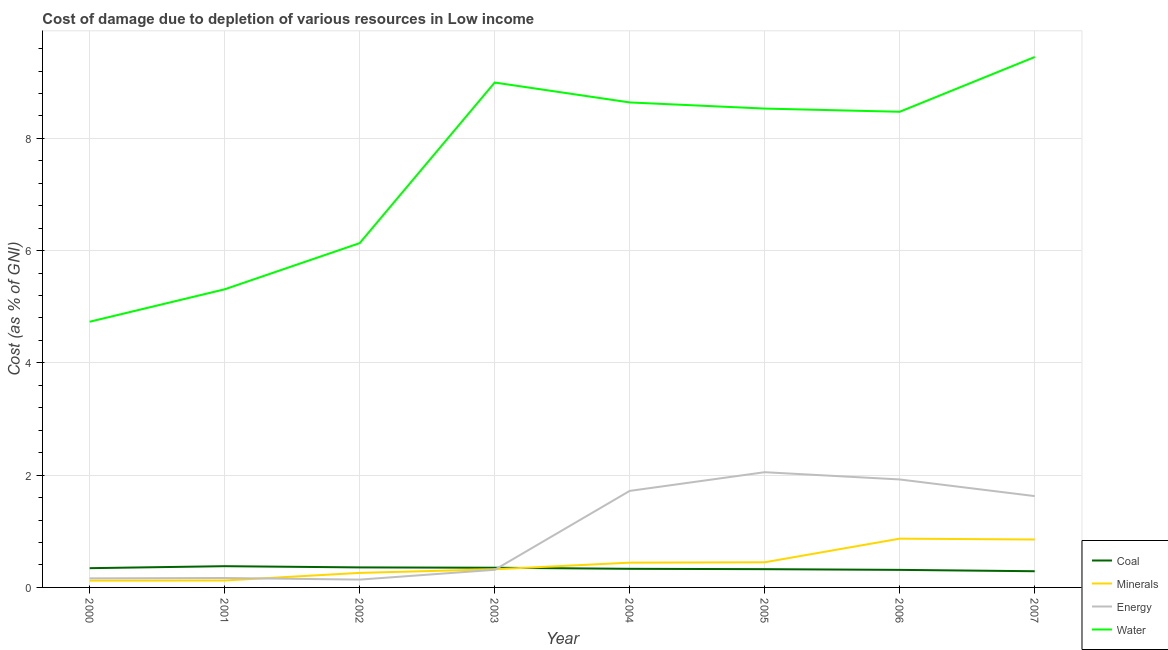Is the number of lines equal to the number of legend labels?
Make the answer very short. Yes. What is the cost of damage due to depletion of water in 2000?
Offer a very short reply. 4.73. Across all years, what is the maximum cost of damage due to depletion of coal?
Provide a succinct answer. 0.38. Across all years, what is the minimum cost of damage due to depletion of coal?
Offer a terse response. 0.29. In which year was the cost of damage due to depletion of energy maximum?
Provide a short and direct response. 2005. What is the total cost of damage due to depletion of water in the graph?
Ensure brevity in your answer.  60.27. What is the difference between the cost of damage due to depletion of minerals in 2005 and that in 2007?
Provide a succinct answer. -0.41. What is the difference between the cost of damage due to depletion of minerals in 2001 and the cost of damage due to depletion of water in 2006?
Your answer should be compact. -8.35. What is the average cost of damage due to depletion of water per year?
Offer a very short reply. 7.53. In the year 2005, what is the difference between the cost of damage due to depletion of minerals and cost of damage due to depletion of coal?
Make the answer very short. 0.12. In how many years, is the cost of damage due to depletion of energy greater than 4.8 %?
Provide a succinct answer. 0. What is the ratio of the cost of damage due to depletion of water in 2004 to that in 2006?
Your answer should be very brief. 1.02. What is the difference between the highest and the second highest cost of damage due to depletion of energy?
Your answer should be very brief. 0.13. What is the difference between the highest and the lowest cost of damage due to depletion of energy?
Ensure brevity in your answer.  1.91. In how many years, is the cost of damage due to depletion of water greater than the average cost of damage due to depletion of water taken over all years?
Ensure brevity in your answer.  5. Is it the case that in every year, the sum of the cost of damage due to depletion of coal and cost of damage due to depletion of energy is greater than the sum of cost of damage due to depletion of minerals and cost of damage due to depletion of water?
Provide a succinct answer. No. Does the cost of damage due to depletion of water monotonically increase over the years?
Offer a very short reply. No. How many years are there in the graph?
Your response must be concise. 8. What is the difference between two consecutive major ticks on the Y-axis?
Your response must be concise. 2. Does the graph contain any zero values?
Your response must be concise. No. Where does the legend appear in the graph?
Provide a short and direct response. Bottom right. How are the legend labels stacked?
Offer a very short reply. Vertical. What is the title of the graph?
Ensure brevity in your answer.  Cost of damage due to depletion of various resources in Low income . Does "Revenue mobilization" appear as one of the legend labels in the graph?
Your response must be concise. No. What is the label or title of the Y-axis?
Provide a succinct answer. Cost (as % of GNI). What is the Cost (as % of GNI) in Coal in 2000?
Offer a very short reply. 0.34. What is the Cost (as % of GNI) of Minerals in 2000?
Your answer should be very brief. 0.12. What is the Cost (as % of GNI) of Energy in 2000?
Your response must be concise. 0.16. What is the Cost (as % of GNI) of Water in 2000?
Ensure brevity in your answer.  4.73. What is the Cost (as % of GNI) in Coal in 2001?
Keep it short and to the point. 0.38. What is the Cost (as % of GNI) in Minerals in 2001?
Provide a succinct answer. 0.12. What is the Cost (as % of GNI) in Energy in 2001?
Keep it short and to the point. 0.17. What is the Cost (as % of GNI) in Water in 2001?
Make the answer very short. 5.31. What is the Cost (as % of GNI) in Coal in 2002?
Offer a very short reply. 0.36. What is the Cost (as % of GNI) in Minerals in 2002?
Provide a succinct answer. 0.26. What is the Cost (as % of GNI) of Energy in 2002?
Your answer should be very brief. 0.14. What is the Cost (as % of GNI) in Water in 2002?
Your answer should be very brief. 6.13. What is the Cost (as % of GNI) of Coal in 2003?
Ensure brevity in your answer.  0.35. What is the Cost (as % of GNI) in Minerals in 2003?
Give a very brief answer. 0.32. What is the Cost (as % of GNI) of Energy in 2003?
Keep it short and to the point. 0.31. What is the Cost (as % of GNI) in Water in 2003?
Keep it short and to the point. 8.99. What is the Cost (as % of GNI) in Coal in 2004?
Make the answer very short. 0.33. What is the Cost (as % of GNI) of Minerals in 2004?
Provide a short and direct response. 0.44. What is the Cost (as % of GNI) of Energy in 2004?
Offer a very short reply. 1.72. What is the Cost (as % of GNI) in Water in 2004?
Offer a terse response. 8.64. What is the Cost (as % of GNI) of Coal in 2005?
Your answer should be compact. 0.33. What is the Cost (as % of GNI) of Minerals in 2005?
Offer a terse response. 0.45. What is the Cost (as % of GNI) in Energy in 2005?
Ensure brevity in your answer.  2.05. What is the Cost (as % of GNI) in Water in 2005?
Make the answer very short. 8.53. What is the Cost (as % of GNI) of Coal in 2006?
Make the answer very short. 0.31. What is the Cost (as % of GNI) of Minerals in 2006?
Your response must be concise. 0.87. What is the Cost (as % of GNI) of Energy in 2006?
Make the answer very short. 1.92. What is the Cost (as % of GNI) in Water in 2006?
Provide a succinct answer. 8.47. What is the Cost (as % of GNI) of Coal in 2007?
Keep it short and to the point. 0.29. What is the Cost (as % of GNI) of Minerals in 2007?
Your response must be concise. 0.85. What is the Cost (as % of GNI) in Energy in 2007?
Make the answer very short. 1.63. What is the Cost (as % of GNI) of Water in 2007?
Keep it short and to the point. 9.45. Across all years, what is the maximum Cost (as % of GNI) of Coal?
Ensure brevity in your answer.  0.38. Across all years, what is the maximum Cost (as % of GNI) of Minerals?
Give a very brief answer. 0.87. Across all years, what is the maximum Cost (as % of GNI) in Energy?
Give a very brief answer. 2.05. Across all years, what is the maximum Cost (as % of GNI) in Water?
Offer a very short reply. 9.45. Across all years, what is the minimum Cost (as % of GNI) in Coal?
Provide a short and direct response. 0.29. Across all years, what is the minimum Cost (as % of GNI) of Minerals?
Give a very brief answer. 0.12. Across all years, what is the minimum Cost (as % of GNI) of Energy?
Provide a short and direct response. 0.14. Across all years, what is the minimum Cost (as % of GNI) in Water?
Offer a very short reply. 4.73. What is the total Cost (as % of GNI) of Coal in the graph?
Keep it short and to the point. 2.69. What is the total Cost (as % of GNI) in Minerals in the graph?
Make the answer very short. 3.44. What is the total Cost (as % of GNI) of Energy in the graph?
Keep it short and to the point. 8.11. What is the total Cost (as % of GNI) of Water in the graph?
Make the answer very short. 60.27. What is the difference between the Cost (as % of GNI) of Coal in 2000 and that in 2001?
Provide a succinct answer. -0.04. What is the difference between the Cost (as % of GNI) in Minerals in 2000 and that in 2001?
Keep it short and to the point. -0. What is the difference between the Cost (as % of GNI) of Energy in 2000 and that in 2001?
Your response must be concise. -0.01. What is the difference between the Cost (as % of GNI) in Water in 2000 and that in 2001?
Your answer should be very brief. -0.58. What is the difference between the Cost (as % of GNI) in Coal in 2000 and that in 2002?
Ensure brevity in your answer.  -0.01. What is the difference between the Cost (as % of GNI) of Minerals in 2000 and that in 2002?
Your answer should be very brief. -0.14. What is the difference between the Cost (as % of GNI) in Energy in 2000 and that in 2002?
Your answer should be compact. 0.02. What is the difference between the Cost (as % of GNI) of Water in 2000 and that in 2002?
Keep it short and to the point. -1.4. What is the difference between the Cost (as % of GNI) of Coal in 2000 and that in 2003?
Your answer should be compact. -0.01. What is the difference between the Cost (as % of GNI) in Minerals in 2000 and that in 2003?
Keep it short and to the point. -0.2. What is the difference between the Cost (as % of GNI) of Energy in 2000 and that in 2003?
Your answer should be compact. -0.15. What is the difference between the Cost (as % of GNI) of Water in 2000 and that in 2003?
Make the answer very short. -4.26. What is the difference between the Cost (as % of GNI) of Coal in 2000 and that in 2004?
Provide a succinct answer. 0.01. What is the difference between the Cost (as % of GNI) of Minerals in 2000 and that in 2004?
Your answer should be very brief. -0.32. What is the difference between the Cost (as % of GNI) of Energy in 2000 and that in 2004?
Your answer should be very brief. -1.56. What is the difference between the Cost (as % of GNI) in Water in 2000 and that in 2004?
Offer a very short reply. -3.91. What is the difference between the Cost (as % of GNI) of Coal in 2000 and that in 2005?
Make the answer very short. 0.02. What is the difference between the Cost (as % of GNI) in Minerals in 2000 and that in 2005?
Your response must be concise. -0.33. What is the difference between the Cost (as % of GNI) in Energy in 2000 and that in 2005?
Provide a succinct answer. -1.89. What is the difference between the Cost (as % of GNI) of Water in 2000 and that in 2005?
Give a very brief answer. -3.8. What is the difference between the Cost (as % of GNI) of Coal in 2000 and that in 2006?
Make the answer very short. 0.03. What is the difference between the Cost (as % of GNI) in Minerals in 2000 and that in 2006?
Ensure brevity in your answer.  -0.75. What is the difference between the Cost (as % of GNI) of Energy in 2000 and that in 2006?
Ensure brevity in your answer.  -1.76. What is the difference between the Cost (as % of GNI) in Water in 2000 and that in 2006?
Provide a succinct answer. -3.74. What is the difference between the Cost (as % of GNI) of Coal in 2000 and that in 2007?
Provide a short and direct response. 0.05. What is the difference between the Cost (as % of GNI) of Minerals in 2000 and that in 2007?
Provide a succinct answer. -0.73. What is the difference between the Cost (as % of GNI) in Energy in 2000 and that in 2007?
Offer a very short reply. -1.47. What is the difference between the Cost (as % of GNI) of Water in 2000 and that in 2007?
Keep it short and to the point. -4.72. What is the difference between the Cost (as % of GNI) in Coal in 2001 and that in 2002?
Keep it short and to the point. 0.02. What is the difference between the Cost (as % of GNI) of Minerals in 2001 and that in 2002?
Give a very brief answer. -0.14. What is the difference between the Cost (as % of GNI) of Energy in 2001 and that in 2002?
Keep it short and to the point. 0.03. What is the difference between the Cost (as % of GNI) in Water in 2001 and that in 2002?
Give a very brief answer. -0.82. What is the difference between the Cost (as % of GNI) of Coal in 2001 and that in 2003?
Your answer should be compact. 0.03. What is the difference between the Cost (as % of GNI) of Minerals in 2001 and that in 2003?
Your answer should be compact. -0.2. What is the difference between the Cost (as % of GNI) of Energy in 2001 and that in 2003?
Your answer should be very brief. -0.15. What is the difference between the Cost (as % of GNI) of Water in 2001 and that in 2003?
Provide a short and direct response. -3.68. What is the difference between the Cost (as % of GNI) of Coal in 2001 and that in 2004?
Your answer should be compact. 0.05. What is the difference between the Cost (as % of GNI) of Minerals in 2001 and that in 2004?
Offer a terse response. -0.32. What is the difference between the Cost (as % of GNI) in Energy in 2001 and that in 2004?
Ensure brevity in your answer.  -1.55. What is the difference between the Cost (as % of GNI) of Water in 2001 and that in 2004?
Your response must be concise. -3.33. What is the difference between the Cost (as % of GNI) in Coal in 2001 and that in 2005?
Offer a very short reply. 0.05. What is the difference between the Cost (as % of GNI) of Minerals in 2001 and that in 2005?
Keep it short and to the point. -0.32. What is the difference between the Cost (as % of GNI) in Energy in 2001 and that in 2005?
Your answer should be compact. -1.89. What is the difference between the Cost (as % of GNI) of Water in 2001 and that in 2005?
Ensure brevity in your answer.  -3.22. What is the difference between the Cost (as % of GNI) in Coal in 2001 and that in 2006?
Offer a very short reply. 0.07. What is the difference between the Cost (as % of GNI) of Minerals in 2001 and that in 2006?
Offer a very short reply. -0.74. What is the difference between the Cost (as % of GNI) of Energy in 2001 and that in 2006?
Your answer should be very brief. -1.76. What is the difference between the Cost (as % of GNI) in Water in 2001 and that in 2006?
Offer a very short reply. -3.16. What is the difference between the Cost (as % of GNI) of Coal in 2001 and that in 2007?
Your answer should be compact. 0.09. What is the difference between the Cost (as % of GNI) in Minerals in 2001 and that in 2007?
Your answer should be very brief. -0.73. What is the difference between the Cost (as % of GNI) in Energy in 2001 and that in 2007?
Keep it short and to the point. -1.46. What is the difference between the Cost (as % of GNI) of Water in 2001 and that in 2007?
Offer a terse response. -4.14. What is the difference between the Cost (as % of GNI) of Coal in 2002 and that in 2003?
Make the answer very short. 0.01. What is the difference between the Cost (as % of GNI) in Minerals in 2002 and that in 2003?
Make the answer very short. -0.06. What is the difference between the Cost (as % of GNI) in Energy in 2002 and that in 2003?
Provide a succinct answer. -0.17. What is the difference between the Cost (as % of GNI) of Water in 2002 and that in 2003?
Provide a short and direct response. -2.86. What is the difference between the Cost (as % of GNI) in Coal in 2002 and that in 2004?
Ensure brevity in your answer.  0.02. What is the difference between the Cost (as % of GNI) of Minerals in 2002 and that in 2004?
Offer a very short reply. -0.18. What is the difference between the Cost (as % of GNI) of Energy in 2002 and that in 2004?
Your answer should be very brief. -1.58. What is the difference between the Cost (as % of GNI) of Water in 2002 and that in 2004?
Offer a very short reply. -2.51. What is the difference between the Cost (as % of GNI) in Coal in 2002 and that in 2005?
Provide a succinct answer. 0.03. What is the difference between the Cost (as % of GNI) of Minerals in 2002 and that in 2005?
Your answer should be very brief. -0.19. What is the difference between the Cost (as % of GNI) in Energy in 2002 and that in 2005?
Keep it short and to the point. -1.91. What is the difference between the Cost (as % of GNI) in Water in 2002 and that in 2005?
Ensure brevity in your answer.  -2.4. What is the difference between the Cost (as % of GNI) in Coal in 2002 and that in 2006?
Provide a short and direct response. 0.04. What is the difference between the Cost (as % of GNI) of Minerals in 2002 and that in 2006?
Your answer should be very brief. -0.61. What is the difference between the Cost (as % of GNI) in Energy in 2002 and that in 2006?
Ensure brevity in your answer.  -1.78. What is the difference between the Cost (as % of GNI) in Water in 2002 and that in 2006?
Make the answer very short. -2.34. What is the difference between the Cost (as % of GNI) in Coal in 2002 and that in 2007?
Keep it short and to the point. 0.07. What is the difference between the Cost (as % of GNI) in Minerals in 2002 and that in 2007?
Offer a very short reply. -0.59. What is the difference between the Cost (as % of GNI) in Energy in 2002 and that in 2007?
Ensure brevity in your answer.  -1.49. What is the difference between the Cost (as % of GNI) in Water in 2002 and that in 2007?
Your answer should be very brief. -3.32. What is the difference between the Cost (as % of GNI) of Coal in 2003 and that in 2004?
Keep it short and to the point. 0.02. What is the difference between the Cost (as % of GNI) of Minerals in 2003 and that in 2004?
Provide a succinct answer. -0.12. What is the difference between the Cost (as % of GNI) in Energy in 2003 and that in 2004?
Offer a terse response. -1.41. What is the difference between the Cost (as % of GNI) in Water in 2003 and that in 2004?
Offer a terse response. 0.35. What is the difference between the Cost (as % of GNI) of Coal in 2003 and that in 2005?
Your answer should be compact. 0.03. What is the difference between the Cost (as % of GNI) in Minerals in 2003 and that in 2005?
Provide a short and direct response. -0.12. What is the difference between the Cost (as % of GNI) of Energy in 2003 and that in 2005?
Offer a terse response. -1.74. What is the difference between the Cost (as % of GNI) of Water in 2003 and that in 2005?
Make the answer very short. 0.46. What is the difference between the Cost (as % of GNI) in Coal in 2003 and that in 2006?
Offer a terse response. 0.04. What is the difference between the Cost (as % of GNI) of Minerals in 2003 and that in 2006?
Make the answer very short. -0.55. What is the difference between the Cost (as % of GNI) of Energy in 2003 and that in 2006?
Ensure brevity in your answer.  -1.61. What is the difference between the Cost (as % of GNI) of Water in 2003 and that in 2006?
Your answer should be very brief. 0.52. What is the difference between the Cost (as % of GNI) of Coal in 2003 and that in 2007?
Provide a short and direct response. 0.06. What is the difference between the Cost (as % of GNI) of Minerals in 2003 and that in 2007?
Make the answer very short. -0.53. What is the difference between the Cost (as % of GNI) of Energy in 2003 and that in 2007?
Provide a short and direct response. -1.31. What is the difference between the Cost (as % of GNI) in Water in 2003 and that in 2007?
Your answer should be very brief. -0.46. What is the difference between the Cost (as % of GNI) in Coal in 2004 and that in 2005?
Ensure brevity in your answer.  0.01. What is the difference between the Cost (as % of GNI) in Minerals in 2004 and that in 2005?
Offer a terse response. -0.01. What is the difference between the Cost (as % of GNI) in Energy in 2004 and that in 2005?
Your answer should be compact. -0.33. What is the difference between the Cost (as % of GNI) in Water in 2004 and that in 2005?
Offer a terse response. 0.11. What is the difference between the Cost (as % of GNI) of Coal in 2004 and that in 2006?
Your answer should be very brief. 0.02. What is the difference between the Cost (as % of GNI) of Minerals in 2004 and that in 2006?
Provide a succinct answer. -0.43. What is the difference between the Cost (as % of GNI) of Energy in 2004 and that in 2006?
Your answer should be compact. -0.2. What is the difference between the Cost (as % of GNI) of Water in 2004 and that in 2006?
Make the answer very short. 0.17. What is the difference between the Cost (as % of GNI) of Coal in 2004 and that in 2007?
Provide a succinct answer. 0.04. What is the difference between the Cost (as % of GNI) of Minerals in 2004 and that in 2007?
Provide a short and direct response. -0.41. What is the difference between the Cost (as % of GNI) of Energy in 2004 and that in 2007?
Make the answer very short. 0.09. What is the difference between the Cost (as % of GNI) in Water in 2004 and that in 2007?
Make the answer very short. -0.81. What is the difference between the Cost (as % of GNI) in Coal in 2005 and that in 2006?
Give a very brief answer. 0.01. What is the difference between the Cost (as % of GNI) of Minerals in 2005 and that in 2006?
Ensure brevity in your answer.  -0.42. What is the difference between the Cost (as % of GNI) in Energy in 2005 and that in 2006?
Offer a terse response. 0.13. What is the difference between the Cost (as % of GNI) in Water in 2005 and that in 2006?
Provide a succinct answer. 0.06. What is the difference between the Cost (as % of GNI) of Coal in 2005 and that in 2007?
Give a very brief answer. 0.04. What is the difference between the Cost (as % of GNI) of Minerals in 2005 and that in 2007?
Make the answer very short. -0.41. What is the difference between the Cost (as % of GNI) of Energy in 2005 and that in 2007?
Provide a short and direct response. 0.43. What is the difference between the Cost (as % of GNI) of Water in 2005 and that in 2007?
Provide a succinct answer. -0.92. What is the difference between the Cost (as % of GNI) of Coal in 2006 and that in 2007?
Offer a terse response. 0.02. What is the difference between the Cost (as % of GNI) in Minerals in 2006 and that in 2007?
Your answer should be very brief. 0.02. What is the difference between the Cost (as % of GNI) of Energy in 2006 and that in 2007?
Ensure brevity in your answer.  0.3. What is the difference between the Cost (as % of GNI) of Water in 2006 and that in 2007?
Provide a succinct answer. -0.98. What is the difference between the Cost (as % of GNI) of Coal in 2000 and the Cost (as % of GNI) of Minerals in 2001?
Provide a short and direct response. 0.22. What is the difference between the Cost (as % of GNI) in Coal in 2000 and the Cost (as % of GNI) in Energy in 2001?
Your answer should be compact. 0.18. What is the difference between the Cost (as % of GNI) of Coal in 2000 and the Cost (as % of GNI) of Water in 2001?
Your answer should be very brief. -4.97. What is the difference between the Cost (as % of GNI) of Minerals in 2000 and the Cost (as % of GNI) of Energy in 2001?
Keep it short and to the point. -0.05. What is the difference between the Cost (as % of GNI) in Minerals in 2000 and the Cost (as % of GNI) in Water in 2001?
Your answer should be very brief. -5.19. What is the difference between the Cost (as % of GNI) of Energy in 2000 and the Cost (as % of GNI) of Water in 2001?
Offer a terse response. -5.15. What is the difference between the Cost (as % of GNI) of Coal in 2000 and the Cost (as % of GNI) of Minerals in 2002?
Offer a very short reply. 0.08. What is the difference between the Cost (as % of GNI) of Coal in 2000 and the Cost (as % of GNI) of Energy in 2002?
Give a very brief answer. 0.2. What is the difference between the Cost (as % of GNI) in Coal in 2000 and the Cost (as % of GNI) in Water in 2002?
Make the answer very short. -5.79. What is the difference between the Cost (as % of GNI) in Minerals in 2000 and the Cost (as % of GNI) in Energy in 2002?
Give a very brief answer. -0.02. What is the difference between the Cost (as % of GNI) of Minerals in 2000 and the Cost (as % of GNI) of Water in 2002?
Provide a succinct answer. -6.01. What is the difference between the Cost (as % of GNI) in Energy in 2000 and the Cost (as % of GNI) in Water in 2002?
Offer a very short reply. -5.97. What is the difference between the Cost (as % of GNI) in Coal in 2000 and the Cost (as % of GNI) in Minerals in 2003?
Offer a terse response. 0.02. What is the difference between the Cost (as % of GNI) in Coal in 2000 and the Cost (as % of GNI) in Energy in 2003?
Keep it short and to the point. 0.03. What is the difference between the Cost (as % of GNI) of Coal in 2000 and the Cost (as % of GNI) of Water in 2003?
Provide a short and direct response. -8.65. What is the difference between the Cost (as % of GNI) of Minerals in 2000 and the Cost (as % of GNI) of Energy in 2003?
Keep it short and to the point. -0.19. What is the difference between the Cost (as % of GNI) in Minerals in 2000 and the Cost (as % of GNI) in Water in 2003?
Ensure brevity in your answer.  -8.87. What is the difference between the Cost (as % of GNI) of Energy in 2000 and the Cost (as % of GNI) of Water in 2003?
Your answer should be very brief. -8.83. What is the difference between the Cost (as % of GNI) in Coal in 2000 and the Cost (as % of GNI) in Minerals in 2004?
Keep it short and to the point. -0.1. What is the difference between the Cost (as % of GNI) in Coal in 2000 and the Cost (as % of GNI) in Energy in 2004?
Provide a short and direct response. -1.38. What is the difference between the Cost (as % of GNI) in Coal in 2000 and the Cost (as % of GNI) in Water in 2004?
Provide a short and direct response. -8.3. What is the difference between the Cost (as % of GNI) in Minerals in 2000 and the Cost (as % of GNI) in Energy in 2004?
Provide a short and direct response. -1.6. What is the difference between the Cost (as % of GNI) of Minerals in 2000 and the Cost (as % of GNI) of Water in 2004?
Ensure brevity in your answer.  -8.52. What is the difference between the Cost (as % of GNI) in Energy in 2000 and the Cost (as % of GNI) in Water in 2004?
Ensure brevity in your answer.  -8.48. What is the difference between the Cost (as % of GNI) in Coal in 2000 and the Cost (as % of GNI) in Minerals in 2005?
Your answer should be compact. -0.1. What is the difference between the Cost (as % of GNI) of Coal in 2000 and the Cost (as % of GNI) of Energy in 2005?
Keep it short and to the point. -1.71. What is the difference between the Cost (as % of GNI) in Coal in 2000 and the Cost (as % of GNI) in Water in 2005?
Provide a short and direct response. -8.19. What is the difference between the Cost (as % of GNI) in Minerals in 2000 and the Cost (as % of GNI) in Energy in 2005?
Provide a succinct answer. -1.93. What is the difference between the Cost (as % of GNI) in Minerals in 2000 and the Cost (as % of GNI) in Water in 2005?
Your response must be concise. -8.41. What is the difference between the Cost (as % of GNI) in Energy in 2000 and the Cost (as % of GNI) in Water in 2005?
Make the answer very short. -8.37. What is the difference between the Cost (as % of GNI) of Coal in 2000 and the Cost (as % of GNI) of Minerals in 2006?
Ensure brevity in your answer.  -0.53. What is the difference between the Cost (as % of GNI) of Coal in 2000 and the Cost (as % of GNI) of Energy in 2006?
Your answer should be very brief. -1.58. What is the difference between the Cost (as % of GNI) of Coal in 2000 and the Cost (as % of GNI) of Water in 2006?
Provide a succinct answer. -8.13. What is the difference between the Cost (as % of GNI) of Minerals in 2000 and the Cost (as % of GNI) of Energy in 2006?
Offer a very short reply. -1.8. What is the difference between the Cost (as % of GNI) in Minerals in 2000 and the Cost (as % of GNI) in Water in 2006?
Make the answer very short. -8.35. What is the difference between the Cost (as % of GNI) of Energy in 2000 and the Cost (as % of GNI) of Water in 2006?
Ensure brevity in your answer.  -8.31. What is the difference between the Cost (as % of GNI) in Coal in 2000 and the Cost (as % of GNI) in Minerals in 2007?
Provide a short and direct response. -0.51. What is the difference between the Cost (as % of GNI) in Coal in 2000 and the Cost (as % of GNI) in Energy in 2007?
Offer a very short reply. -1.28. What is the difference between the Cost (as % of GNI) of Coal in 2000 and the Cost (as % of GNI) of Water in 2007?
Give a very brief answer. -9.11. What is the difference between the Cost (as % of GNI) in Minerals in 2000 and the Cost (as % of GNI) in Energy in 2007?
Give a very brief answer. -1.51. What is the difference between the Cost (as % of GNI) of Minerals in 2000 and the Cost (as % of GNI) of Water in 2007?
Your response must be concise. -9.33. What is the difference between the Cost (as % of GNI) in Energy in 2000 and the Cost (as % of GNI) in Water in 2007?
Your response must be concise. -9.29. What is the difference between the Cost (as % of GNI) of Coal in 2001 and the Cost (as % of GNI) of Minerals in 2002?
Ensure brevity in your answer.  0.12. What is the difference between the Cost (as % of GNI) of Coal in 2001 and the Cost (as % of GNI) of Energy in 2002?
Make the answer very short. 0.24. What is the difference between the Cost (as % of GNI) of Coal in 2001 and the Cost (as % of GNI) of Water in 2002?
Your answer should be compact. -5.76. What is the difference between the Cost (as % of GNI) in Minerals in 2001 and the Cost (as % of GNI) in Energy in 2002?
Give a very brief answer. -0.02. What is the difference between the Cost (as % of GNI) in Minerals in 2001 and the Cost (as % of GNI) in Water in 2002?
Ensure brevity in your answer.  -6.01. What is the difference between the Cost (as % of GNI) of Energy in 2001 and the Cost (as % of GNI) of Water in 2002?
Your answer should be very brief. -5.97. What is the difference between the Cost (as % of GNI) in Coal in 2001 and the Cost (as % of GNI) in Minerals in 2003?
Your response must be concise. 0.06. What is the difference between the Cost (as % of GNI) of Coal in 2001 and the Cost (as % of GNI) of Energy in 2003?
Ensure brevity in your answer.  0.06. What is the difference between the Cost (as % of GNI) in Coal in 2001 and the Cost (as % of GNI) in Water in 2003?
Provide a succinct answer. -8.62. What is the difference between the Cost (as % of GNI) of Minerals in 2001 and the Cost (as % of GNI) of Energy in 2003?
Your answer should be very brief. -0.19. What is the difference between the Cost (as % of GNI) in Minerals in 2001 and the Cost (as % of GNI) in Water in 2003?
Offer a very short reply. -8.87. What is the difference between the Cost (as % of GNI) in Energy in 2001 and the Cost (as % of GNI) in Water in 2003?
Your answer should be very brief. -8.83. What is the difference between the Cost (as % of GNI) in Coal in 2001 and the Cost (as % of GNI) in Minerals in 2004?
Make the answer very short. -0.06. What is the difference between the Cost (as % of GNI) of Coal in 2001 and the Cost (as % of GNI) of Energy in 2004?
Your answer should be very brief. -1.34. What is the difference between the Cost (as % of GNI) in Coal in 2001 and the Cost (as % of GNI) in Water in 2004?
Offer a very short reply. -8.26. What is the difference between the Cost (as % of GNI) of Minerals in 2001 and the Cost (as % of GNI) of Energy in 2004?
Offer a terse response. -1.6. What is the difference between the Cost (as % of GNI) in Minerals in 2001 and the Cost (as % of GNI) in Water in 2004?
Provide a short and direct response. -8.52. What is the difference between the Cost (as % of GNI) in Energy in 2001 and the Cost (as % of GNI) in Water in 2004?
Your response must be concise. -8.47. What is the difference between the Cost (as % of GNI) of Coal in 2001 and the Cost (as % of GNI) of Minerals in 2005?
Provide a succinct answer. -0.07. What is the difference between the Cost (as % of GNI) of Coal in 2001 and the Cost (as % of GNI) of Energy in 2005?
Your answer should be very brief. -1.67. What is the difference between the Cost (as % of GNI) of Coal in 2001 and the Cost (as % of GNI) of Water in 2005?
Your answer should be very brief. -8.15. What is the difference between the Cost (as % of GNI) in Minerals in 2001 and the Cost (as % of GNI) in Energy in 2005?
Your response must be concise. -1.93. What is the difference between the Cost (as % of GNI) in Minerals in 2001 and the Cost (as % of GNI) in Water in 2005?
Your answer should be compact. -8.41. What is the difference between the Cost (as % of GNI) of Energy in 2001 and the Cost (as % of GNI) of Water in 2005?
Offer a very short reply. -8.36. What is the difference between the Cost (as % of GNI) of Coal in 2001 and the Cost (as % of GNI) of Minerals in 2006?
Provide a succinct answer. -0.49. What is the difference between the Cost (as % of GNI) of Coal in 2001 and the Cost (as % of GNI) of Energy in 2006?
Give a very brief answer. -1.55. What is the difference between the Cost (as % of GNI) in Coal in 2001 and the Cost (as % of GNI) in Water in 2006?
Offer a terse response. -8.1. What is the difference between the Cost (as % of GNI) in Minerals in 2001 and the Cost (as % of GNI) in Energy in 2006?
Offer a terse response. -1.8. What is the difference between the Cost (as % of GNI) in Minerals in 2001 and the Cost (as % of GNI) in Water in 2006?
Provide a succinct answer. -8.35. What is the difference between the Cost (as % of GNI) in Energy in 2001 and the Cost (as % of GNI) in Water in 2006?
Your answer should be very brief. -8.31. What is the difference between the Cost (as % of GNI) of Coal in 2001 and the Cost (as % of GNI) of Minerals in 2007?
Your answer should be compact. -0.48. What is the difference between the Cost (as % of GNI) of Coal in 2001 and the Cost (as % of GNI) of Energy in 2007?
Your answer should be very brief. -1.25. What is the difference between the Cost (as % of GNI) of Coal in 2001 and the Cost (as % of GNI) of Water in 2007?
Provide a short and direct response. -9.07. What is the difference between the Cost (as % of GNI) of Minerals in 2001 and the Cost (as % of GNI) of Energy in 2007?
Offer a terse response. -1.5. What is the difference between the Cost (as % of GNI) of Minerals in 2001 and the Cost (as % of GNI) of Water in 2007?
Offer a very short reply. -9.33. What is the difference between the Cost (as % of GNI) of Energy in 2001 and the Cost (as % of GNI) of Water in 2007?
Offer a very short reply. -9.28. What is the difference between the Cost (as % of GNI) of Coal in 2002 and the Cost (as % of GNI) of Minerals in 2003?
Ensure brevity in your answer.  0.03. What is the difference between the Cost (as % of GNI) of Coal in 2002 and the Cost (as % of GNI) of Energy in 2003?
Your answer should be very brief. 0.04. What is the difference between the Cost (as % of GNI) in Coal in 2002 and the Cost (as % of GNI) in Water in 2003?
Give a very brief answer. -8.64. What is the difference between the Cost (as % of GNI) in Minerals in 2002 and the Cost (as % of GNI) in Energy in 2003?
Give a very brief answer. -0.05. What is the difference between the Cost (as % of GNI) in Minerals in 2002 and the Cost (as % of GNI) in Water in 2003?
Provide a short and direct response. -8.74. What is the difference between the Cost (as % of GNI) of Energy in 2002 and the Cost (as % of GNI) of Water in 2003?
Offer a terse response. -8.86. What is the difference between the Cost (as % of GNI) in Coal in 2002 and the Cost (as % of GNI) in Minerals in 2004?
Give a very brief answer. -0.08. What is the difference between the Cost (as % of GNI) of Coal in 2002 and the Cost (as % of GNI) of Energy in 2004?
Your answer should be compact. -1.36. What is the difference between the Cost (as % of GNI) of Coal in 2002 and the Cost (as % of GNI) of Water in 2004?
Ensure brevity in your answer.  -8.28. What is the difference between the Cost (as % of GNI) in Minerals in 2002 and the Cost (as % of GNI) in Energy in 2004?
Your response must be concise. -1.46. What is the difference between the Cost (as % of GNI) of Minerals in 2002 and the Cost (as % of GNI) of Water in 2004?
Make the answer very short. -8.38. What is the difference between the Cost (as % of GNI) of Energy in 2002 and the Cost (as % of GNI) of Water in 2004?
Offer a very short reply. -8.5. What is the difference between the Cost (as % of GNI) in Coal in 2002 and the Cost (as % of GNI) in Minerals in 2005?
Make the answer very short. -0.09. What is the difference between the Cost (as % of GNI) in Coal in 2002 and the Cost (as % of GNI) in Energy in 2005?
Provide a succinct answer. -1.7. What is the difference between the Cost (as % of GNI) in Coal in 2002 and the Cost (as % of GNI) in Water in 2005?
Your response must be concise. -8.17. What is the difference between the Cost (as % of GNI) of Minerals in 2002 and the Cost (as % of GNI) of Energy in 2005?
Keep it short and to the point. -1.79. What is the difference between the Cost (as % of GNI) in Minerals in 2002 and the Cost (as % of GNI) in Water in 2005?
Your answer should be very brief. -8.27. What is the difference between the Cost (as % of GNI) in Energy in 2002 and the Cost (as % of GNI) in Water in 2005?
Offer a terse response. -8.39. What is the difference between the Cost (as % of GNI) of Coal in 2002 and the Cost (as % of GNI) of Minerals in 2006?
Your response must be concise. -0.51. What is the difference between the Cost (as % of GNI) of Coal in 2002 and the Cost (as % of GNI) of Energy in 2006?
Ensure brevity in your answer.  -1.57. What is the difference between the Cost (as % of GNI) in Coal in 2002 and the Cost (as % of GNI) in Water in 2006?
Give a very brief answer. -8.12. What is the difference between the Cost (as % of GNI) of Minerals in 2002 and the Cost (as % of GNI) of Energy in 2006?
Ensure brevity in your answer.  -1.66. What is the difference between the Cost (as % of GNI) in Minerals in 2002 and the Cost (as % of GNI) in Water in 2006?
Give a very brief answer. -8.22. What is the difference between the Cost (as % of GNI) of Energy in 2002 and the Cost (as % of GNI) of Water in 2006?
Your answer should be very brief. -8.33. What is the difference between the Cost (as % of GNI) of Coal in 2002 and the Cost (as % of GNI) of Minerals in 2007?
Keep it short and to the point. -0.5. What is the difference between the Cost (as % of GNI) in Coal in 2002 and the Cost (as % of GNI) in Energy in 2007?
Provide a succinct answer. -1.27. What is the difference between the Cost (as % of GNI) of Coal in 2002 and the Cost (as % of GNI) of Water in 2007?
Offer a very short reply. -9.09. What is the difference between the Cost (as % of GNI) in Minerals in 2002 and the Cost (as % of GNI) in Energy in 2007?
Your response must be concise. -1.37. What is the difference between the Cost (as % of GNI) of Minerals in 2002 and the Cost (as % of GNI) of Water in 2007?
Your answer should be very brief. -9.19. What is the difference between the Cost (as % of GNI) in Energy in 2002 and the Cost (as % of GNI) in Water in 2007?
Provide a succinct answer. -9.31. What is the difference between the Cost (as % of GNI) in Coal in 2003 and the Cost (as % of GNI) in Minerals in 2004?
Your response must be concise. -0.09. What is the difference between the Cost (as % of GNI) of Coal in 2003 and the Cost (as % of GNI) of Energy in 2004?
Ensure brevity in your answer.  -1.37. What is the difference between the Cost (as % of GNI) in Coal in 2003 and the Cost (as % of GNI) in Water in 2004?
Offer a very short reply. -8.29. What is the difference between the Cost (as % of GNI) of Minerals in 2003 and the Cost (as % of GNI) of Energy in 2004?
Give a very brief answer. -1.4. What is the difference between the Cost (as % of GNI) in Minerals in 2003 and the Cost (as % of GNI) in Water in 2004?
Keep it short and to the point. -8.32. What is the difference between the Cost (as % of GNI) of Energy in 2003 and the Cost (as % of GNI) of Water in 2004?
Your answer should be very brief. -8.33. What is the difference between the Cost (as % of GNI) in Coal in 2003 and the Cost (as % of GNI) in Minerals in 2005?
Make the answer very short. -0.1. What is the difference between the Cost (as % of GNI) of Coal in 2003 and the Cost (as % of GNI) of Energy in 2005?
Offer a terse response. -1.7. What is the difference between the Cost (as % of GNI) of Coal in 2003 and the Cost (as % of GNI) of Water in 2005?
Keep it short and to the point. -8.18. What is the difference between the Cost (as % of GNI) in Minerals in 2003 and the Cost (as % of GNI) in Energy in 2005?
Offer a very short reply. -1.73. What is the difference between the Cost (as % of GNI) in Minerals in 2003 and the Cost (as % of GNI) in Water in 2005?
Offer a terse response. -8.21. What is the difference between the Cost (as % of GNI) of Energy in 2003 and the Cost (as % of GNI) of Water in 2005?
Make the answer very short. -8.22. What is the difference between the Cost (as % of GNI) in Coal in 2003 and the Cost (as % of GNI) in Minerals in 2006?
Provide a succinct answer. -0.52. What is the difference between the Cost (as % of GNI) in Coal in 2003 and the Cost (as % of GNI) in Energy in 2006?
Make the answer very short. -1.57. What is the difference between the Cost (as % of GNI) of Coal in 2003 and the Cost (as % of GNI) of Water in 2006?
Your answer should be very brief. -8.12. What is the difference between the Cost (as % of GNI) in Minerals in 2003 and the Cost (as % of GNI) in Energy in 2006?
Your answer should be very brief. -1.6. What is the difference between the Cost (as % of GNI) of Minerals in 2003 and the Cost (as % of GNI) of Water in 2006?
Your answer should be very brief. -8.15. What is the difference between the Cost (as % of GNI) in Energy in 2003 and the Cost (as % of GNI) in Water in 2006?
Provide a succinct answer. -8.16. What is the difference between the Cost (as % of GNI) in Coal in 2003 and the Cost (as % of GNI) in Minerals in 2007?
Keep it short and to the point. -0.5. What is the difference between the Cost (as % of GNI) in Coal in 2003 and the Cost (as % of GNI) in Energy in 2007?
Provide a short and direct response. -1.28. What is the difference between the Cost (as % of GNI) of Coal in 2003 and the Cost (as % of GNI) of Water in 2007?
Give a very brief answer. -9.1. What is the difference between the Cost (as % of GNI) of Minerals in 2003 and the Cost (as % of GNI) of Energy in 2007?
Your answer should be compact. -1.3. What is the difference between the Cost (as % of GNI) of Minerals in 2003 and the Cost (as % of GNI) of Water in 2007?
Your answer should be compact. -9.13. What is the difference between the Cost (as % of GNI) of Energy in 2003 and the Cost (as % of GNI) of Water in 2007?
Provide a short and direct response. -9.14. What is the difference between the Cost (as % of GNI) in Coal in 2004 and the Cost (as % of GNI) in Minerals in 2005?
Keep it short and to the point. -0.12. What is the difference between the Cost (as % of GNI) of Coal in 2004 and the Cost (as % of GNI) of Energy in 2005?
Your answer should be compact. -1.72. What is the difference between the Cost (as % of GNI) in Coal in 2004 and the Cost (as % of GNI) in Water in 2005?
Offer a terse response. -8.2. What is the difference between the Cost (as % of GNI) of Minerals in 2004 and the Cost (as % of GNI) of Energy in 2005?
Offer a terse response. -1.61. What is the difference between the Cost (as % of GNI) in Minerals in 2004 and the Cost (as % of GNI) in Water in 2005?
Your response must be concise. -8.09. What is the difference between the Cost (as % of GNI) of Energy in 2004 and the Cost (as % of GNI) of Water in 2005?
Provide a succinct answer. -6.81. What is the difference between the Cost (as % of GNI) in Coal in 2004 and the Cost (as % of GNI) in Minerals in 2006?
Offer a terse response. -0.54. What is the difference between the Cost (as % of GNI) in Coal in 2004 and the Cost (as % of GNI) in Energy in 2006?
Provide a succinct answer. -1.59. What is the difference between the Cost (as % of GNI) of Coal in 2004 and the Cost (as % of GNI) of Water in 2006?
Make the answer very short. -8.14. What is the difference between the Cost (as % of GNI) in Minerals in 2004 and the Cost (as % of GNI) in Energy in 2006?
Keep it short and to the point. -1.48. What is the difference between the Cost (as % of GNI) of Minerals in 2004 and the Cost (as % of GNI) of Water in 2006?
Your answer should be compact. -8.03. What is the difference between the Cost (as % of GNI) in Energy in 2004 and the Cost (as % of GNI) in Water in 2006?
Ensure brevity in your answer.  -6.75. What is the difference between the Cost (as % of GNI) of Coal in 2004 and the Cost (as % of GNI) of Minerals in 2007?
Offer a terse response. -0.52. What is the difference between the Cost (as % of GNI) of Coal in 2004 and the Cost (as % of GNI) of Energy in 2007?
Provide a succinct answer. -1.3. What is the difference between the Cost (as % of GNI) of Coal in 2004 and the Cost (as % of GNI) of Water in 2007?
Give a very brief answer. -9.12. What is the difference between the Cost (as % of GNI) of Minerals in 2004 and the Cost (as % of GNI) of Energy in 2007?
Keep it short and to the point. -1.19. What is the difference between the Cost (as % of GNI) in Minerals in 2004 and the Cost (as % of GNI) in Water in 2007?
Give a very brief answer. -9.01. What is the difference between the Cost (as % of GNI) of Energy in 2004 and the Cost (as % of GNI) of Water in 2007?
Offer a terse response. -7.73. What is the difference between the Cost (as % of GNI) of Coal in 2005 and the Cost (as % of GNI) of Minerals in 2006?
Your answer should be compact. -0.54. What is the difference between the Cost (as % of GNI) of Coal in 2005 and the Cost (as % of GNI) of Energy in 2006?
Offer a very short reply. -1.6. What is the difference between the Cost (as % of GNI) in Coal in 2005 and the Cost (as % of GNI) in Water in 2006?
Your answer should be compact. -8.15. What is the difference between the Cost (as % of GNI) in Minerals in 2005 and the Cost (as % of GNI) in Energy in 2006?
Keep it short and to the point. -1.48. What is the difference between the Cost (as % of GNI) in Minerals in 2005 and the Cost (as % of GNI) in Water in 2006?
Keep it short and to the point. -8.03. What is the difference between the Cost (as % of GNI) in Energy in 2005 and the Cost (as % of GNI) in Water in 2006?
Ensure brevity in your answer.  -6.42. What is the difference between the Cost (as % of GNI) of Coal in 2005 and the Cost (as % of GNI) of Minerals in 2007?
Offer a terse response. -0.53. What is the difference between the Cost (as % of GNI) of Coal in 2005 and the Cost (as % of GNI) of Energy in 2007?
Your answer should be very brief. -1.3. What is the difference between the Cost (as % of GNI) in Coal in 2005 and the Cost (as % of GNI) in Water in 2007?
Your answer should be very brief. -9.12. What is the difference between the Cost (as % of GNI) of Minerals in 2005 and the Cost (as % of GNI) of Energy in 2007?
Provide a succinct answer. -1.18. What is the difference between the Cost (as % of GNI) in Minerals in 2005 and the Cost (as % of GNI) in Water in 2007?
Ensure brevity in your answer.  -9. What is the difference between the Cost (as % of GNI) in Energy in 2005 and the Cost (as % of GNI) in Water in 2007?
Keep it short and to the point. -7.4. What is the difference between the Cost (as % of GNI) of Coal in 2006 and the Cost (as % of GNI) of Minerals in 2007?
Ensure brevity in your answer.  -0.54. What is the difference between the Cost (as % of GNI) of Coal in 2006 and the Cost (as % of GNI) of Energy in 2007?
Your answer should be very brief. -1.31. What is the difference between the Cost (as % of GNI) of Coal in 2006 and the Cost (as % of GNI) of Water in 2007?
Offer a terse response. -9.14. What is the difference between the Cost (as % of GNI) in Minerals in 2006 and the Cost (as % of GNI) in Energy in 2007?
Provide a succinct answer. -0.76. What is the difference between the Cost (as % of GNI) of Minerals in 2006 and the Cost (as % of GNI) of Water in 2007?
Offer a terse response. -8.58. What is the difference between the Cost (as % of GNI) of Energy in 2006 and the Cost (as % of GNI) of Water in 2007?
Provide a short and direct response. -7.53. What is the average Cost (as % of GNI) of Coal per year?
Give a very brief answer. 0.34. What is the average Cost (as % of GNI) of Minerals per year?
Ensure brevity in your answer.  0.43. What is the average Cost (as % of GNI) in Energy per year?
Provide a succinct answer. 1.01. What is the average Cost (as % of GNI) of Water per year?
Your response must be concise. 7.53. In the year 2000, what is the difference between the Cost (as % of GNI) of Coal and Cost (as % of GNI) of Minerals?
Your answer should be very brief. 0.22. In the year 2000, what is the difference between the Cost (as % of GNI) in Coal and Cost (as % of GNI) in Energy?
Provide a succinct answer. 0.18. In the year 2000, what is the difference between the Cost (as % of GNI) in Coal and Cost (as % of GNI) in Water?
Provide a succinct answer. -4.39. In the year 2000, what is the difference between the Cost (as % of GNI) in Minerals and Cost (as % of GNI) in Energy?
Your answer should be compact. -0.04. In the year 2000, what is the difference between the Cost (as % of GNI) in Minerals and Cost (as % of GNI) in Water?
Offer a very short reply. -4.61. In the year 2000, what is the difference between the Cost (as % of GNI) of Energy and Cost (as % of GNI) of Water?
Ensure brevity in your answer.  -4.57. In the year 2001, what is the difference between the Cost (as % of GNI) in Coal and Cost (as % of GNI) in Minerals?
Give a very brief answer. 0.25. In the year 2001, what is the difference between the Cost (as % of GNI) in Coal and Cost (as % of GNI) in Energy?
Your response must be concise. 0.21. In the year 2001, what is the difference between the Cost (as % of GNI) of Coal and Cost (as % of GNI) of Water?
Provide a succinct answer. -4.93. In the year 2001, what is the difference between the Cost (as % of GNI) of Minerals and Cost (as % of GNI) of Energy?
Keep it short and to the point. -0.04. In the year 2001, what is the difference between the Cost (as % of GNI) in Minerals and Cost (as % of GNI) in Water?
Give a very brief answer. -5.19. In the year 2001, what is the difference between the Cost (as % of GNI) in Energy and Cost (as % of GNI) in Water?
Offer a terse response. -5.14. In the year 2002, what is the difference between the Cost (as % of GNI) of Coal and Cost (as % of GNI) of Minerals?
Your answer should be compact. 0.1. In the year 2002, what is the difference between the Cost (as % of GNI) in Coal and Cost (as % of GNI) in Energy?
Give a very brief answer. 0.22. In the year 2002, what is the difference between the Cost (as % of GNI) of Coal and Cost (as % of GNI) of Water?
Make the answer very short. -5.78. In the year 2002, what is the difference between the Cost (as % of GNI) of Minerals and Cost (as % of GNI) of Energy?
Give a very brief answer. 0.12. In the year 2002, what is the difference between the Cost (as % of GNI) in Minerals and Cost (as % of GNI) in Water?
Provide a succinct answer. -5.87. In the year 2002, what is the difference between the Cost (as % of GNI) of Energy and Cost (as % of GNI) of Water?
Ensure brevity in your answer.  -5.99. In the year 2003, what is the difference between the Cost (as % of GNI) of Coal and Cost (as % of GNI) of Minerals?
Your answer should be very brief. 0.03. In the year 2003, what is the difference between the Cost (as % of GNI) of Coal and Cost (as % of GNI) of Energy?
Your answer should be very brief. 0.04. In the year 2003, what is the difference between the Cost (as % of GNI) in Coal and Cost (as % of GNI) in Water?
Your answer should be compact. -8.64. In the year 2003, what is the difference between the Cost (as % of GNI) in Minerals and Cost (as % of GNI) in Energy?
Your response must be concise. 0.01. In the year 2003, what is the difference between the Cost (as % of GNI) in Minerals and Cost (as % of GNI) in Water?
Keep it short and to the point. -8.67. In the year 2003, what is the difference between the Cost (as % of GNI) of Energy and Cost (as % of GNI) of Water?
Offer a very short reply. -8.68. In the year 2004, what is the difference between the Cost (as % of GNI) of Coal and Cost (as % of GNI) of Minerals?
Make the answer very short. -0.11. In the year 2004, what is the difference between the Cost (as % of GNI) in Coal and Cost (as % of GNI) in Energy?
Your answer should be compact. -1.39. In the year 2004, what is the difference between the Cost (as % of GNI) in Coal and Cost (as % of GNI) in Water?
Ensure brevity in your answer.  -8.31. In the year 2004, what is the difference between the Cost (as % of GNI) of Minerals and Cost (as % of GNI) of Energy?
Your response must be concise. -1.28. In the year 2004, what is the difference between the Cost (as % of GNI) of Minerals and Cost (as % of GNI) of Water?
Ensure brevity in your answer.  -8.2. In the year 2004, what is the difference between the Cost (as % of GNI) of Energy and Cost (as % of GNI) of Water?
Provide a succinct answer. -6.92. In the year 2005, what is the difference between the Cost (as % of GNI) of Coal and Cost (as % of GNI) of Minerals?
Your answer should be very brief. -0.12. In the year 2005, what is the difference between the Cost (as % of GNI) of Coal and Cost (as % of GNI) of Energy?
Offer a terse response. -1.73. In the year 2005, what is the difference between the Cost (as % of GNI) of Coal and Cost (as % of GNI) of Water?
Your answer should be very brief. -8.21. In the year 2005, what is the difference between the Cost (as % of GNI) in Minerals and Cost (as % of GNI) in Energy?
Make the answer very short. -1.6. In the year 2005, what is the difference between the Cost (as % of GNI) in Minerals and Cost (as % of GNI) in Water?
Offer a terse response. -8.08. In the year 2005, what is the difference between the Cost (as % of GNI) of Energy and Cost (as % of GNI) of Water?
Offer a terse response. -6.48. In the year 2006, what is the difference between the Cost (as % of GNI) of Coal and Cost (as % of GNI) of Minerals?
Your answer should be very brief. -0.56. In the year 2006, what is the difference between the Cost (as % of GNI) in Coal and Cost (as % of GNI) in Energy?
Provide a succinct answer. -1.61. In the year 2006, what is the difference between the Cost (as % of GNI) of Coal and Cost (as % of GNI) of Water?
Offer a terse response. -8.16. In the year 2006, what is the difference between the Cost (as % of GNI) of Minerals and Cost (as % of GNI) of Energy?
Ensure brevity in your answer.  -1.05. In the year 2006, what is the difference between the Cost (as % of GNI) in Minerals and Cost (as % of GNI) in Water?
Your answer should be very brief. -7.61. In the year 2006, what is the difference between the Cost (as % of GNI) in Energy and Cost (as % of GNI) in Water?
Offer a very short reply. -6.55. In the year 2007, what is the difference between the Cost (as % of GNI) in Coal and Cost (as % of GNI) in Minerals?
Your response must be concise. -0.57. In the year 2007, what is the difference between the Cost (as % of GNI) of Coal and Cost (as % of GNI) of Energy?
Provide a succinct answer. -1.34. In the year 2007, what is the difference between the Cost (as % of GNI) of Coal and Cost (as % of GNI) of Water?
Your answer should be compact. -9.16. In the year 2007, what is the difference between the Cost (as % of GNI) in Minerals and Cost (as % of GNI) in Energy?
Offer a terse response. -0.77. In the year 2007, what is the difference between the Cost (as % of GNI) of Minerals and Cost (as % of GNI) of Water?
Offer a terse response. -8.6. In the year 2007, what is the difference between the Cost (as % of GNI) in Energy and Cost (as % of GNI) in Water?
Your answer should be very brief. -7.82. What is the ratio of the Cost (as % of GNI) in Coal in 2000 to that in 2001?
Offer a terse response. 0.91. What is the ratio of the Cost (as % of GNI) in Minerals in 2000 to that in 2001?
Keep it short and to the point. 0.98. What is the ratio of the Cost (as % of GNI) in Energy in 2000 to that in 2001?
Offer a terse response. 0.96. What is the ratio of the Cost (as % of GNI) in Water in 2000 to that in 2001?
Offer a terse response. 0.89. What is the ratio of the Cost (as % of GNI) of Coal in 2000 to that in 2002?
Provide a succinct answer. 0.96. What is the ratio of the Cost (as % of GNI) of Minerals in 2000 to that in 2002?
Provide a short and direct response. 0.47. What is the ratio of the Cost (as % of GNI) in Energy in 2000 to that in 2002?
Your answer should be very brief. 1.16. What is the ratio of the Cost (as % of GNI) of Water in 2000 to that in 2002?
Provide a short and direct response. 0.77. What is the ratio of the Cost (as % of GNI) of Coal in 2000 to that in 2003?
Offer a very short reply. 0.98. What is the ratio of the Cost (as % of GNI) of Minerals in 2000 to that in 2003?
Your answer should be very brief. 0.38. What is the ratio of the Cost (as % of GNI) in Energy in 2000 to that in 2003?
Make the answer very short. 0.51. What is the ratio of the Cost (as % of GNI) in Water in 2000 to that in 2003?
Provide a succinct answer. 0.53. What is the ratio of the Cost (as % of GNI) in Coal in 2000 to that in 2004?
Provide a succinct answer. 1.03. What is the ratio of the Cost (as % of GNI) in Minerals in 2000 to that in 2004?
Give a very brief answer. 0.28. What is the ratio of the Cost (as % of GNI) in Energy in 2000 to that in 2004?
Provide a short and direct response. 0.09. What is the ratio of the Cost (as % of GNI) of Water in 2000 to that in 2004?
Your answer should be compact. 0.55. What is the ratio of the Cost (as % of GNI) of Coal in 2000 to that in 2005?
Your response must be concise. 1.05. What is the ratio of the Cost (as % of GNI) in Minerals in 2000 to that in 2005?
Your answer should be compact. 0.27. What is the ratio of the Cost (as % of GNI) of Energy in 2000 to that in 2005?
Make the answer very short. 0.08. What is the ratio of the Cost (as % of GNI) of Water in 2000 to that in 2005?
Your answer should be very brief. 0.55. What is the ratio of the Cost (as % of GNI) in Coal in 2000 to that in 2006?
Keep it short and to the point. 1.1. What is the ratio of the Cost (as % of GNI) in Minerals in 2000 to that in 2006?
Make the answer very short. 0.14. What is the ratio of the Cost (as % of GNI) in Energy in 2000 to that in 2006?
Ensure brevity in your answer.  0.08. What is the ratio of the Cost (as % of GNI) of Water in 2000 to that in 2006?
Your answer should be compact. 0.56. What is the ratio of the Cost (as % of GNI) of Coal in 2000 to that in 2007?
Give a very brief answer. 1.19. What is the ratio of the Cost (as % of GNI) of Minerals in 2000 to that in 2007?
Keep it short and to the point. 0.14. What is the ratio of the Cost (as % of GNI) of Energy in 2000 to that in 2007?
Your response must be concise. 0.1. What is the ratio of the Cost (as % of GNI) in Water in 2000 to that in 2007?
Keep it short and to the point. 0.5. What is the ratio of the Cost (as % of GNI) in Coal in 2001 to that in 2002?
Ensure brevity in your answer.  1.06. What is the ratio of the Cost (as % of GNI) in Minerals in 2001 to that in 2002?
Your answer should be very brief. 0.48. What is the ratio of the Cost (as % of GNI) in Energy in 2001 to that in 2002?
Make the answer very short. 1.21. What is the ratio of the Cost (as % of GNI) in Water in 2001 to that in 2002?
Provide a succinct answer. 0.87. What is the ratio of the Cost (as % of GNI) of Coal in 2001 to that in 2003?
Offer a terse response. 1.08. What is the ratio of the Cost (as % of GNI) of Minerals in 2001 to that in 2003?
Offer a very short reply. 0.38. What is the ratio of the Cost (as % of GNI) in Energy in 2001 to that in 2003?
Your answer should be very brief. 0.54. What is the ratio of the Cost (as % of GNI) in Water in 2001 to that in 2003?
Give a very brief answer. 0.59. What is the ratio of the Cost (as % of GNI) of Coal in 2001 to that in 2004?
Ensure brevity in your answer.  1.14. What is the ratio of the Cost (as % of GNI) of Minerals in 2001 to that in 2004?
Offer a very short reply. 0.28. What is the ratio of the Cost (as % of GNI) in Energy in 2001 to that in 2004?
Give a very brief answer. 0.1. What is the ratio of the Cost (as % of GNI) of Water in 2001 to that in 2004?
Your answer should be compact. 0.61. What is the ratio of the Cost (as % of GNI) of Coal in 2001 to that in 2005?
Your response must be concise. 1.16. What is the ratio of the Cost (as % of GNI) of Minerals in 2001 to that in 2005?
Provide a short and direct response. 0.28. What is the ratio of the Cost (as % of GNI) in Energy in 2001 to that in 2005?
Give a very brief answer. 0.08. What is the ratio of the Cost (as % of GNI) of Water in 2001 to that in 2005?
Keep it short and to the point. 0.62. What is the ratio of the Cost (as % of GNI) in Coal in 2001 to that in 2006?
Provide a succinct answer. 1.21. What is the ratio of the Cost (as % of GNI) of Minerals in 2001 to that in 2006?
Your answer should be compact. 0.14. What is the ratio of the Cost (as % of GNI) of Energy in 2001 to that in 2006?
Ensure brevity in your answer.  0.09. What is the ratio of the Cost (as % of GNI) in Water in 2001 to that in 2006?
Keep it short and to the point. 0.63. What is the ratio of the Cost (as % of GNI) in Coal in 2001 to that in 2007?
Provide a short and direct response. 1.31. What is the ratio of the Cost (as % of GNI) in Minerals in 2001 to that in 2007?
Make the answer very short. 0.14. What is the ratio of the Cost (as % of GNI) in Energy in 2001 to that in 2007?
Offer a terse response. 0.1. What is the ratio of the Cost (as % of GNI) in Water in 2001 to that in 2007?
Ensure brevity in your answer.  0.56. What is the ratio of the Cost (as % of GNI) of Coal in 2002 to that in 2003?
Provide a short and direct response. 1.02. What is the ratio of the Cost (as % of GNI) in Minerals in 2002 to that in 2003?
Ensure brevity in your answer.  0.8. What is the ratio of the Cost (as % of GNI) in Energy in 2002 to that in 2003?
Give a very brief answer. 0.44. What is the ratio of the Cost (as % of GNI) in Water in 2002 to that in 2003?
Your response must be concise. 0.68. What is the ratio of the Cost (as % of GNI) of Coal in 2002 to that in 2004?
Offer a very short reply. 1.07. What is the ratio of the Cost (as % of GNI) in Minerals in 2002 to that in 2004?
Keep it short and to the point. 0.59. What is the ratio of the Cost (as % of GNI) of Energy in 2002 to that in 2004?
Give a very brief answer. 0.08. What is the ratio of the Cost (as % of GNI) of Water in 2002 to that in 2004?
Keep it short and to the point. 0.71. What is the ratio of the Cost (as % of GNI) of Coal in 2002 to that in 2005?
Your response must be concise. 1.1. What is the ratio of the Cost (as % of GNI) of Minerals in 2002 to that in 2005?
Give a very brief answer. 0.58. What is the ratio of the Cost (as % of GNI) in Energy in 2002 to that in 2005?
Ensure brevity in your answer.  0.07. What is the ratio of the Cost (as % of GNI) in Water in 2002 to that in 2005?
Give a very brief answer. 0.72. What is the ratio of the Cost (as % of GNI) in Coal in 2002 to that in 2006?
Offer a terse response. 1.14. What is the ratio of the Cost (as % of GNI) of Minerals in 2002 to that in 2006?
Make the answer very short. 0.3. What is the ratio of the Cost (as % of GNI) in Energy in 2002 to that in 2006?
Ensure brevity in your answer.  0.07. What is the ratio of the Cost (as % of GNI) in Water in 2002 to that in 2006?
Offer a terse response. 0.72. What is the ratio of the Cost (as % of GNI) of Coal in 2002 to that in 2007?
Provide a succinct answer. 1.24. What is the ratio of the Cost (as % of GNI) of Minerals in 2002 to that in 2007?
Make the answer very short. 0.3. What is the ratio of the Cost (as % of GNI) of Energy in 2002 to that in 2007?
Your answer should be compact. 0.09. What is the ratio of the Cost (as % of GNI) of Water in 2002 to that in 2007?
Ensure brevity in your answer.  0.65. What is the ratio of the Cost (as % of GNI) in Coal in 2003 to that in 2004?
Your response must be concise. 1.06. What is the ratio of the Cost (as % of GNI) in Minerals in 2003 to that in 2004?
Your answer should be very brief. 0.73. What is the ratio of the Cost (as % of GNI) in Energy in 2003 to that in 2004?
Ensure brevity in your answer.  0.18. What is the ratio of the Cost (as % of GNI) in Water in 2003 to that in 2004?
Provide a short and direct response. 1.04. What is the ratio of the Cost (as % of GNI) in Coal in 2003 to that in 2005?
Provide a short and direct response. 1.08. What is the ratio of the Cost (as % of GNI) of Minerals in 2003 to that in 2005?
Ensure brevity in your answer.  0.72. What is the ratio of the Cost (as % of GNI) of Energy in 2003 to that in 2005?
Make the answer very short. 0.15. What is the ratio of the Cost (as % of GNI) of Water in 2003 to that in 2005?
Your answer should be very brief. 1.05. What is the ratio of the Cost (as % of GNI) of Coal in 2003 to that in 2006?
Offer a terse response. 1.12. What is the ratio of the Cost (as % of GNI) in Minerals in 2003 to that in 2006?
Your answer should be compact. 0.37. What is the ratio of the Cost (as % of GNI) in Energy in 2003 to that in 2006?
Offer a terse response. 0.16. What is the ratio of the Cost (as % of GNI) of Water in 2003 to that in 2006?
Offer a very short reply. 1.06. What is the ratio of the Cost (as % of GNI) in Coal in 2003 to that in 2007?
Make the answer very short. 1.22. What is the ratio of the Cost (as % of GNI) of Minerals in 2003 to that in 2007?
Your response must be concise. 0.38. What is the ratio of the Cost (as % of GNI) in Energy in 2003 to that in 2007?
Your response must be concise. 0.19. What is the ratio of the Cost (as % of GNI) in Water in 2003 to that in 2007?
Keep it short and to the point. 0.95. What is the ratio of the Cost (as % of GNI) of Coal in 2004 to that in 2005?
Your response must be concise. 1.02. What is the ratio of the Cost (as % of GNI) of Minerals in 2004 to that in 2005?
Your response must be concise. 0.99. What is the ratio of the Cost (as % of GNI) in Energy in 2004 to that in 2005?
Give a very brief answer. 0.84. What is the ratio of the Cost (as % of GNI) in Water in 2004 to that in 2005?
Make the answer very short. 1.01. What is the ratio of the Cost (as % of GNI) of Coal in 2004 to that in 2006?
Keep it short and to the point. 1.06. What is the ratio of the Cost (as % of GNI) of Minerals in 2004 to that in 2006?
Your answer should be very brief. 0.51. What is the ratio of the Cost (as % of GNI) of Energy in 2004 to that in 2006?
Ensure brevity in your answer.  0.89. What is the ratio of the Cost (as % of GNI) of Water in 2004 to that in 2006?
Keep it short and to the point. 1.02. What is the ratio of the Cost (as % of GNI) in Coal in 2004 to that in 2007?
Provide a short and direct response. 1.15. What is the ratio of the Cost (as % of GNI) in Minerals in 2004 to that in 2007?
Your answer should be compact. 0.52. What is the ratio of the Cost (as % of GNI) of Energy in 2004 to that in 2007?
Your answer should be very brief. 1.06. What is the ratio of the Cost (as % of GNI) of Water in 2004 to that in 2007?
Provide a succinct answer. 0.91. What is the ratio of the Cost (as % of GNI) in Coal in 2005 to that in 2006?
Your answer should be very brief. 1.04. What is the ratio of the Cost (as % of GNI) in Minerals in 2005 to that in 2006?
Give a very brief answer. 0.52. What is the ratio of the Cost (as % of GNI) of Energy in 2005 to that in 2006?
Offer a very short reply. 1.07. What is the ratio of the Cost (as % of GNI) of Water in 2005 to that in 2006?
Your answer should be compact. 1.01. What is the ratio of the Cost (as % of GNI) in Coal in 2005 to that in 2007?
Your answer should be compact. 1.13. What is the ratio of the Cost (as % of GNI) in Minerals in 2005 to that in 2007?
Give a very brief answer. 0.52. What is the ratio of the Cost (as % of GNI) of Energy in 2005 to that in 2007?
Offer a very short reply. 1.26. What is the ratio of the Cost (as % of GNI) in Water in 2005 to that in 2007?
Offer a terse response. 0.9. What is the ratio of the Cost (as % of GNI) of Coal in 2006 to that in 2007?
Your response must be concise. 1.08. What is the ratio of the Cost (as % of GNI) of Minerals in 2006 to that in 2007?
Ensure brevity in your answer.  1.02. What is the ratio of the Cost (as % of GNI) in Energy in 2006 to that in 2007?
Your answer should be very brief. 1.18. What is the ratio of the Cost (as % of GNI) of Water in 2006 to that in 2007?
Provide a short and direct response. 0.9. What is the difference between the highest and the second highest Cost (as % of GNI) in Coal?
Your answer should be very brief. 0.02. What is the difference between the highest and the second highest Cost (as % of GNI) in Minerals?
Keep it short and to the point. 0.02. What is the difference between the highest and the second highest Cost (as % of GNI) of Energy?
Your answer should be very brief. 0.13. What is the difference between the highest and the second highest Cost (as % of GNI) in Water?
Your answer should be very brief. 0.46. What is the difference between the highest and the lowest Cost (as % of GNI) of Coal?
Make the answer very short. 0.09. What is the difference between the highest and the lowest Cost (as % of GNI) in Minerals?
Give a very brief answer. 0.75. What is the difference between the highest and the lowest Cost (as % of GNI) of Energy?
Provide a short and direct response. 1.91. What is the difference between the highest and the lowest Cost (as % of GNI) of Water?
Your answer should be compact. 4.72. 